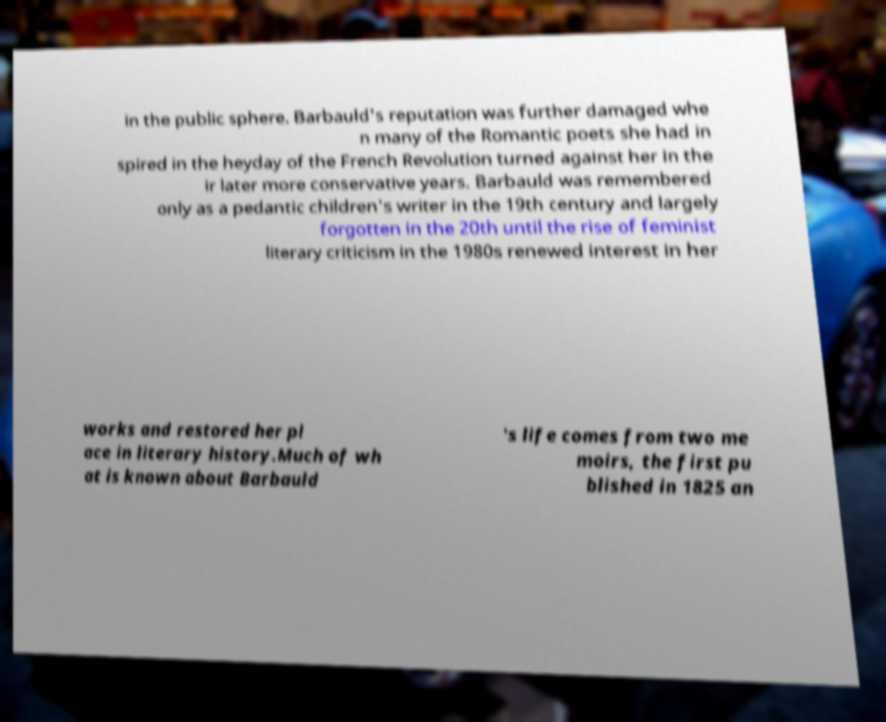There's text embedded in this image that I need extracted. Can you transcribe it verbatim? in the public sphere. Barbauld's reputation was further damaged whe n many of the Romantic poets she had in spired in the heyday of the French Revolution turned against her in the ir later more conservative years. Barbauld was remembered only as a pedantic children's writer in the 19th century and largely forgotten in the 20th until the rise of feminist literary criticism in the 1980s renewed interest in her works and restored her pl ace in literary history.Much of wh at is known about Barbauld 's life comes from two me moirs, the first pu blished in 1825 an 